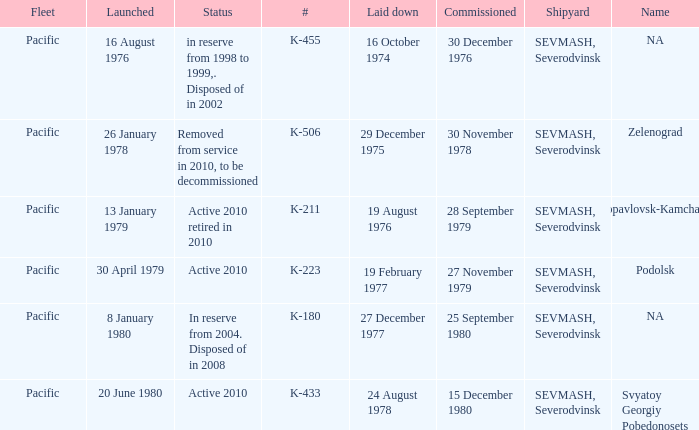What is the status of vessel number K-223? Active 2010. 